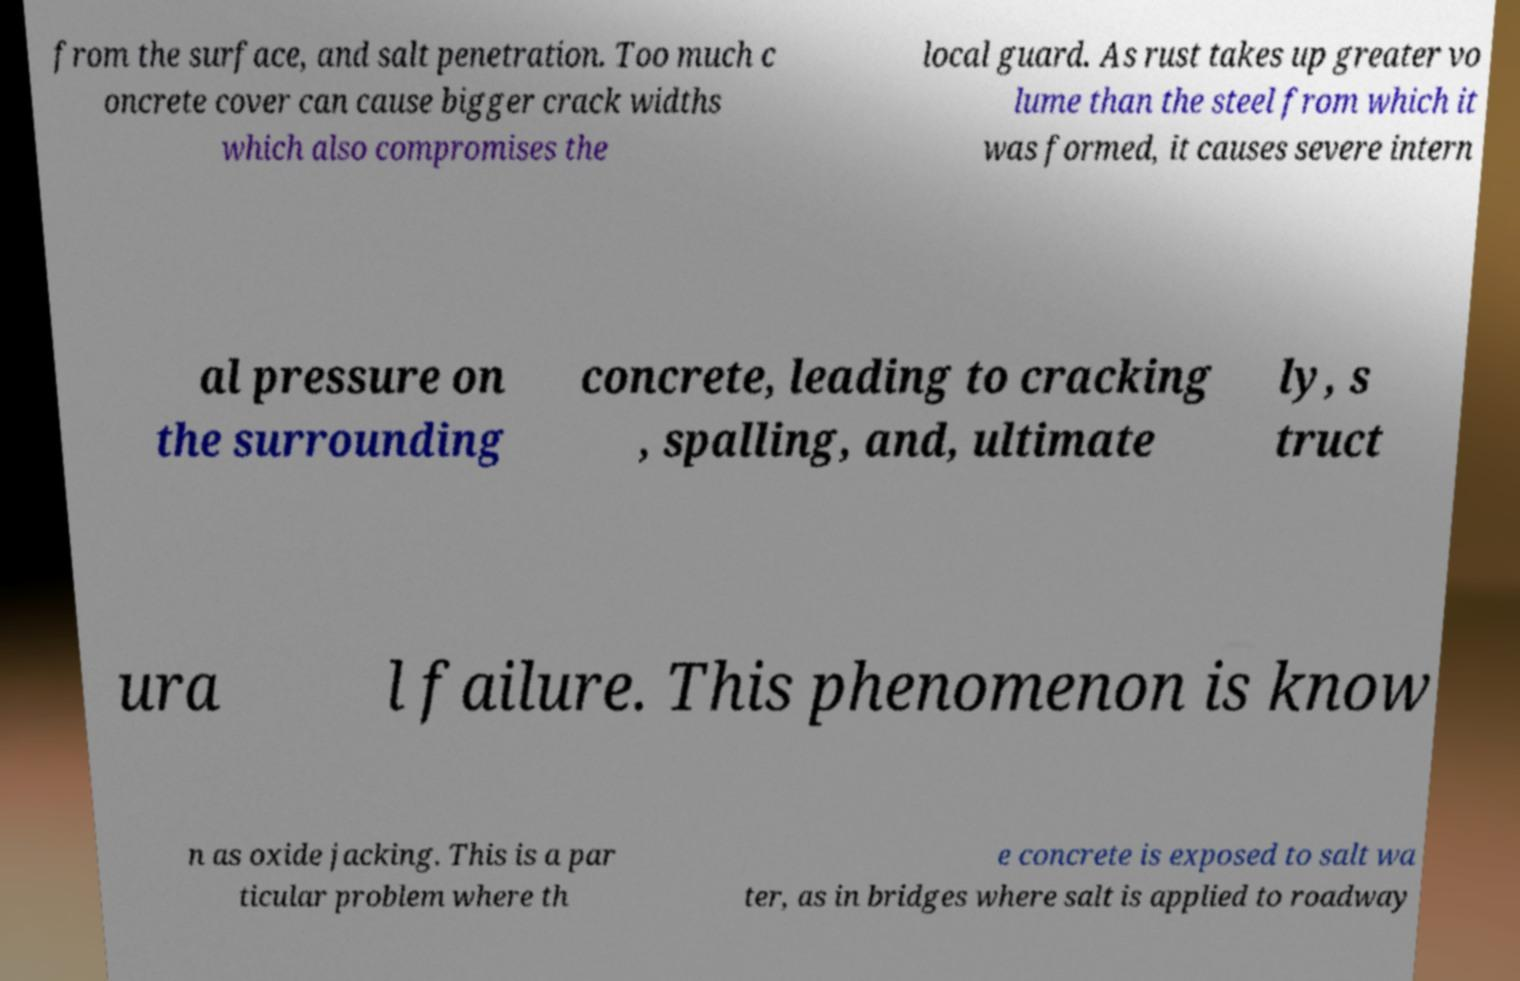Could you assist in decoding the text presented in this image and type it out clearly? from the surface, and salt penetration. Too much c oncrete cover can cause bigger crack widths which also compromises the local guard. As rust takes up greater vo lume than the steel from which it was formed, it causes severe intern al pressure on the surrounding concrete, leading to cracking , spalling, and, ultimate ly, s truct ura l failure. This phenomenon is know n as oxide jacking. This is a par ticular problem where th e concrete is exposed to salt wa ter, as in bridges where salt is applied to roadway 